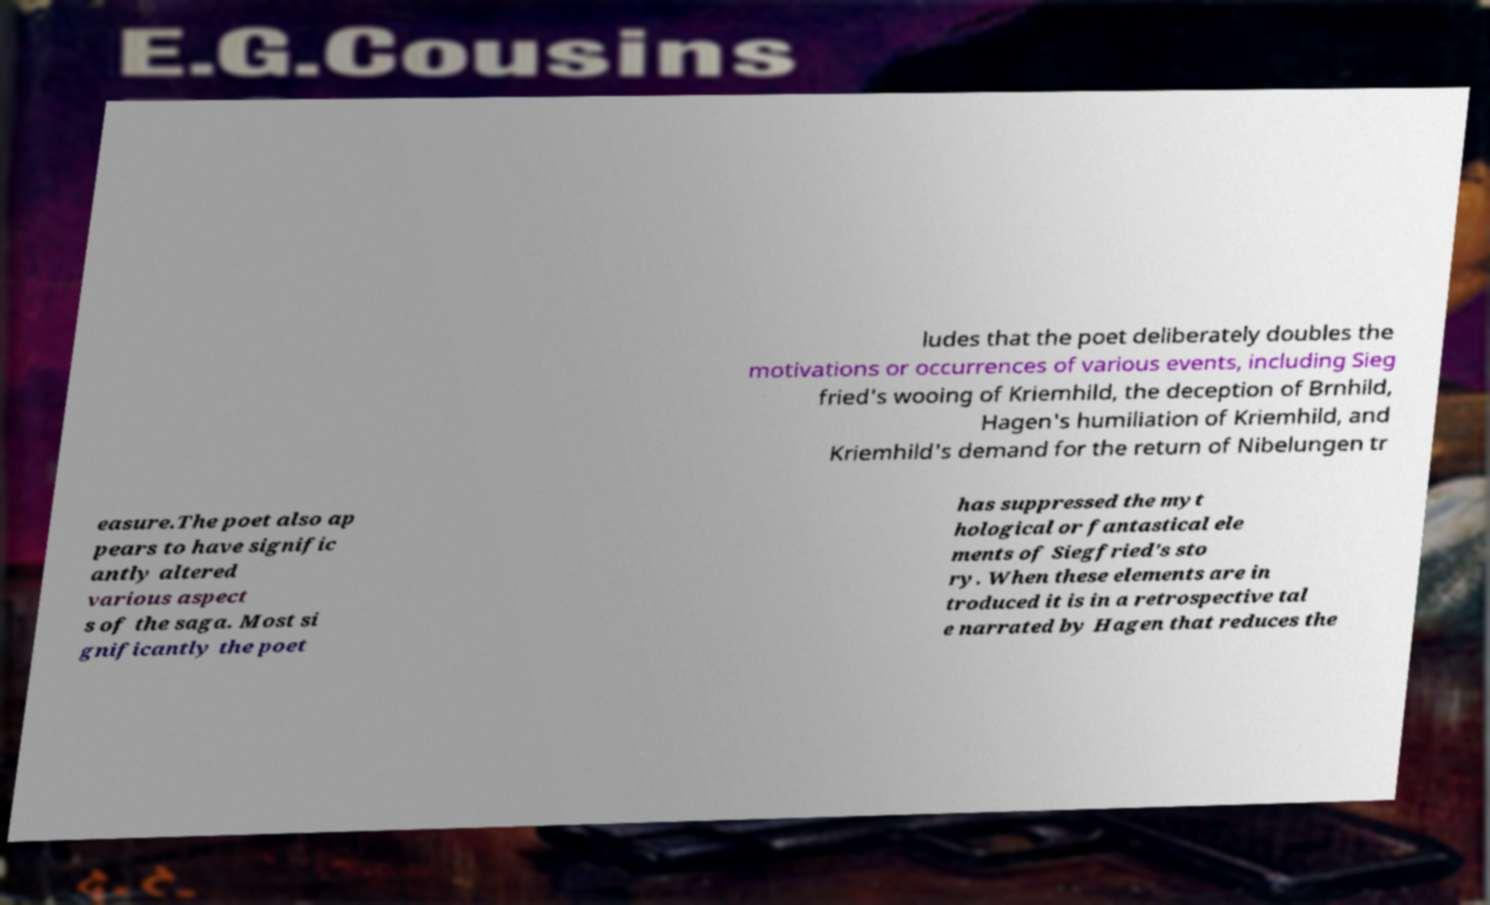I need the written content from this picture converted into text. Can you do that? ludes that the poet deliberately doubles the motivations or occurrences of various events, including Sieg fried's wooing of Kriemhild, the deception of Brnhild, Hagen's humiliation of Kriemhild, and Kriemhild's demand for the return of Nibelungen tr easure.The poet also ap pears to have signific antly altered various aspect s of the saga. Most si gnificantly the poet has suppressed the myt hological or fantastical ele ments of Siegfried's sto ry. When these elements are in troduced it is in a retrospective tal e narrated by Hagen that reduces the 